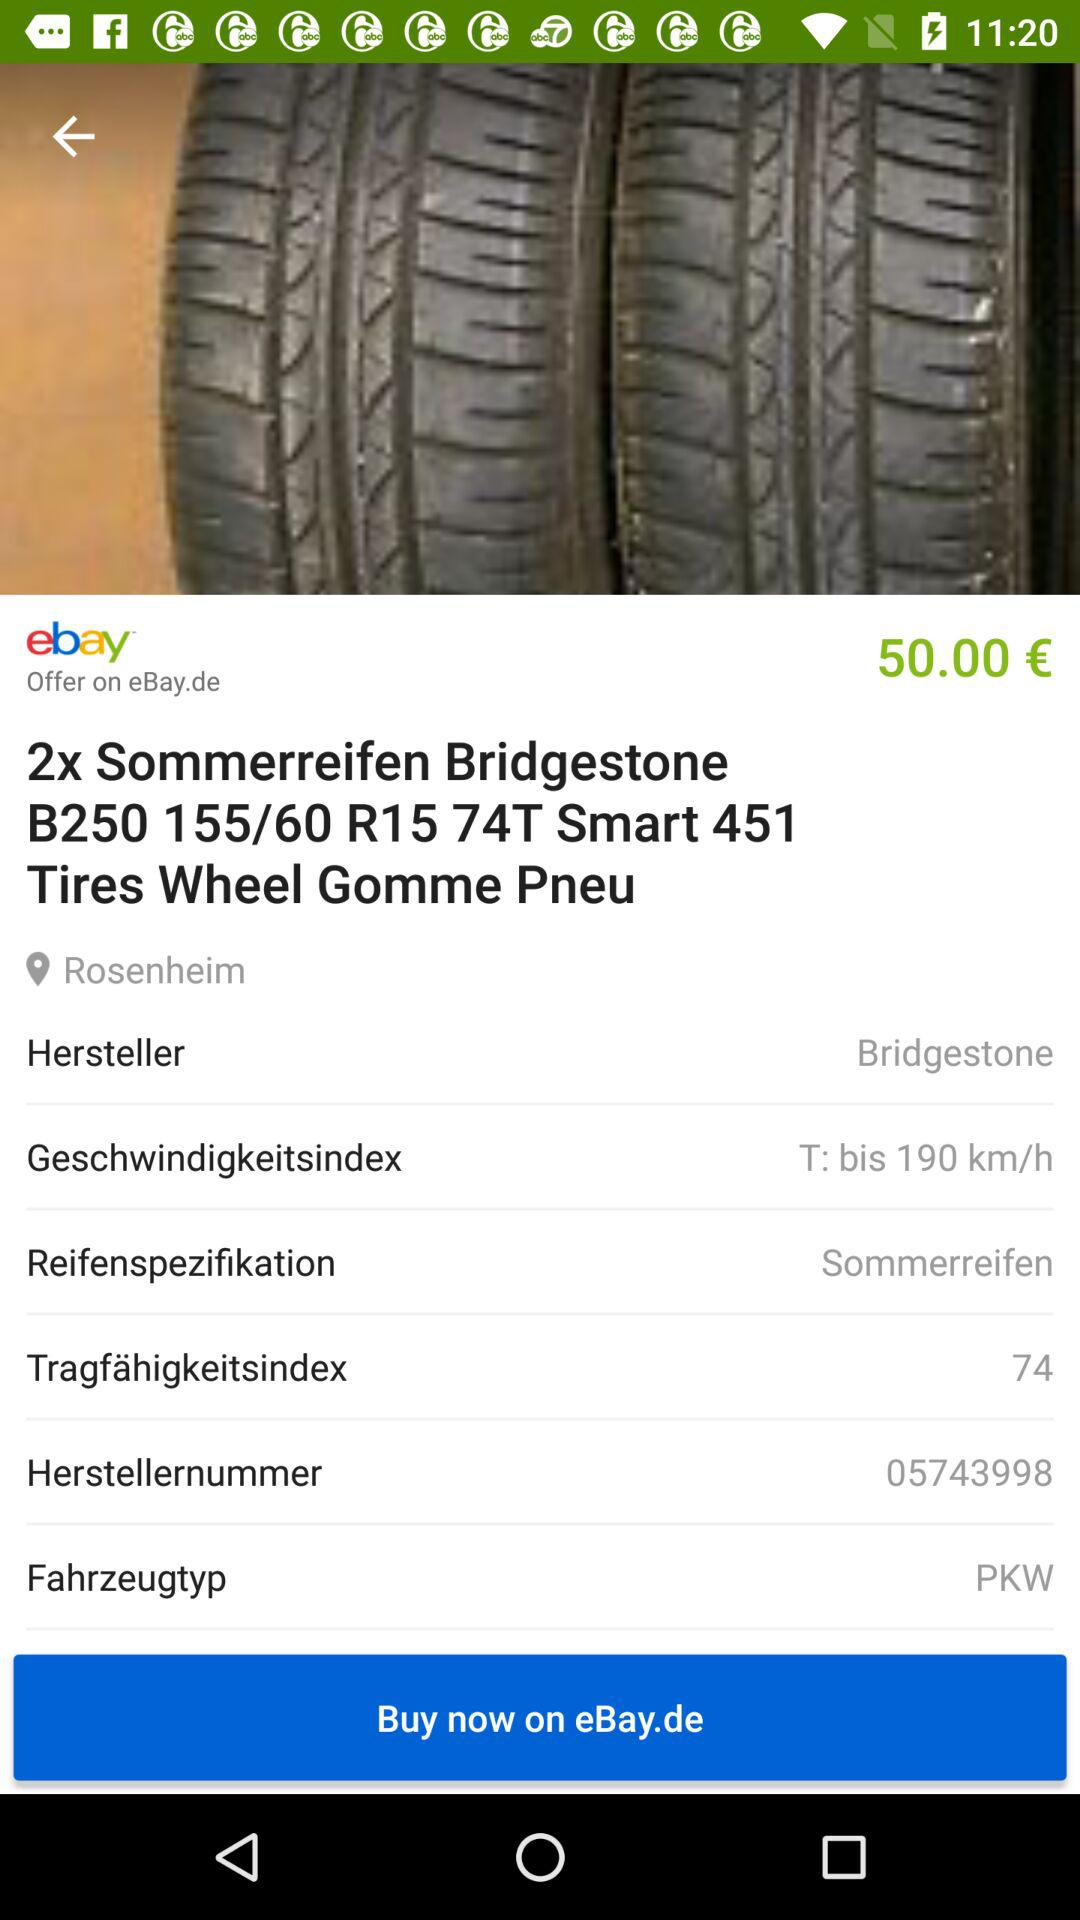What is the location? The location is Rosenheim. 